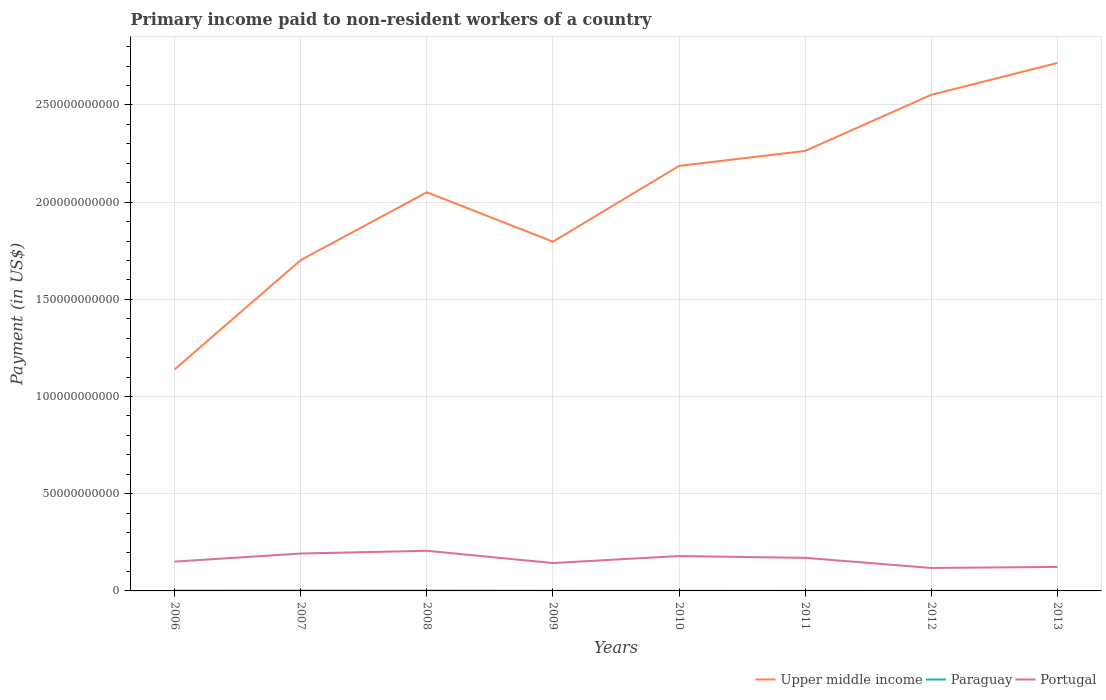Does the line corresponding to Paraguay intersect with the line corresponding to Upper middle income?
Provide a succinct answer. No. Is the number of lines equal to the number of legend labels?
Keep it short and to the point. Yes. Across all years, what is the maximum amount paid to workers in Upper middle income?
Your response must be concise. 1.14e+11. In which year was the amount paid to workers in Paraguay maximum?
Provide a short and direct response. 2011. What is the total amount paid to workers in Upper middle income in the graph?
Keep it short and to the point. -9.45e+09. What is the difference between the highest and the second highest amount paid to workers in Upper middle income?
Offer a very short reply. 1.58e+11. How many years are there in the graph?
Keep it short and to the point. 8. How many legend labels are there?
Offer a terse response. 3. How are the legend labels stacked?
Make the answer very short. Horizontal. What is the title of the graph?
Your answer should be compact. Primary income paid to non-resident workers of a country. Does "Ireland" appear as one of the legend labels in the graph?
Your response must be concise. No. What is the label or title of the Y-axis?
Your answer should be very brief. Payment (in US$). What is the Payment (in US$) of Upper middle income in 2006?
Offer a terse response. 1.14e+11. What is the Payment (in US$) of Paraguay in 2006?
Your response must be concise. 1.44e+08. What is the Payment (in US$) of Portugal in 2006?
Provide a short and direct response. 1.51e+1. What is the Payment (in US$) in Upper middle income in 2007?
Provide a succinct answer. 1.70e+11. What is the Payment (in US$) of Paraguay in 2007?
Ensure brevity in your answer.  1.68e+08. What is the Payment (in US$) in Portugal in 2007?
Provide a succinct answer. 1.92e+1. What is the Payment (in US$) in Upper middle income in 2008?
Offer a terse response. 2.05e+11. What is the Payment (in US$) in Paraguay in 2008?
Provide a succinct answer. 1.39e+08. What is the Payment (in US$) in Portugal in 2008?
Your answer should be very brief. 2.06e+1. What is the Payment (in US$) in Upper middle income in 2009?
Offer a very short reply. 1.80e+11. What is the Payment (in US$) in Paraguay in 2009?
Ensure brevity in your answer.  7.82e+07. What is the Payment (in US$) of Portugal in 2009?
Provide a succinct answer. 1.43e+1. What is the Payment (in US$) of Upper middle income in 2010?
Offer a very short reply. 2.19e+11. What is the Payment (in US$) in Paraguay in 2010?
Ensure brevity in your answer.  4.54e+07. What is the Payment (in US$) in Portugal in 2010?
Offer a very short reply. 1.80e+1. What is the Payment (in US$) in Upper middle income in 2011?
Make the answer very short. 2.26e+11. What is the Payment (in US$) in Paraguay in 2011?
Give a very brief answer. 3.59e+07. What is the Payment (in US$) in Portugal in 2011?
Provide a succinct answer. 1.70e+1. What is the Payment (in US$) in Upper middle income in 2012?
Give a very brief answer. 2.55e+11. What is the Payment (in US$) in Paraguay in 2012?
Provide a short and direct response. 4.21e+07. What is the Payment (in US$) of Portugal in 2012?
Provide a short and direct response. 1.18e+1. What is the Payment (in US$) of Upper middle income in 2013?
Your answer should be compact. 2.72e+11. What is the Payment (in US$) in Paraguay in 2013?
Give a very brief answer. 4.20e+07. What is the Payment (in US$) of Portugal in 2013?
Your response must be concise. 1.23e+1. Across all years, what is the maximum Payment (in US$) in Upper middle income?
Offer a very short reply. 2.72e+11. Across all years, what is the maximum Payment (in US$) of Paraguay?
Ensure brevity in your answer.  1.68e+08. Across all years, what is the maximum Payment (in US$) in Portugal?
Provide a short and direct response. 2.06e+1. Across all years, what is the minimum Payment (in US$) in Upper middle income?
Your answer should be very brief. 1.14e+11. Across all years, what is the minimum Payment (in US$) of Paraguay?
Your response must be concise. 3.59e+07. Across all years, what is the minimum Payment (in US$) in Portugal?
Provide a short and direct response. 1.18e+1. What is the total Payment (in US$) of Upper middle income in the graph?
Your answer should be very brief. 1.64e+12. What is the total Payment (in US$) of Paraguay in the graph?
Keep it short and to the point. 6.96e+08. What is the total Payment (in US$) in Portugal in the graph?
Your answer should be compact. 1.28e+11. What is the difference between the Payment (in US$) in Upper middle income in 2006 and that in 2007?
Provide a short and direct response. -5.63e+1. What is the difference between the Payment (in US$) in Paraguay in 2006 and that in 2007?
Offer a terse response. -2.44e+07. What is the difference between the Payment (in US$) in Portugal in 2006 and that in 2007?
Your answer should be very brief. -4.16e+09. What is the difference between the Payment (in US$) of Upper middle income in 2006 and that in 2008?
Your answer should be very brief. -9.11e+1. What is the difference between the Payment (in US$) of Paraguay in 2006 and that in 2008?
Provide a succinct answer. 4.57e+06. What is the difference between the Payment (in US$) in Portugal in 2006 and that in 2008?
Your response must be concise. -5.55e+09. What is the difference between the Payment (in US$) in Upper middle income in 2006 and that in 2009?
Your answer should be compact. -6.57e+1. What is the difference between the Payment (in US$) in Paraguay in 2006 and that in 2009?
Your response must be concise. 6.58e+07. What is the difference between the Payment (in US$) of Portugal in 2006 and that in 2009?
Your answer should be very brief. 7.43e+08. What is the difference between the Payment (in US$) in Upper middle income in 2006 and that in 2010?
Offer a very short reply. -1.05e+11. What is the difference between the Payment (in US$) in Paraguay in 2006 and that in 2010?
Your answer should be compact. 9.87e+07. What is the difference between the Payment (in US$) of Portugal in 2006 and that in 2010?
Provide a succinct answer. -2.87e+09. What is the difference between the Payment (in US$) of Upper middle income in 2006 and that in 2011?
Give a very brief answer. -1.12e+11. What is the difference between the Payment (in US$) in Paraguay in 2006 and that in 2011?
Make the answer very short. 1.08e+08. What is the difference between the Payment (in US$) in Portugal in 2006 and that in 2011?
Offer a very short reply. -1.92e+09. What is the difference between the Payment (in US$) in Upper middle income in 2006 and that in 2012?
Your answer should be very brief. -1.41e+11. What is the difference between the Payment (in US$) in Paraguay in 2006 and that in 2012?
Offer a very short reply. 1.02e+08. What is the difference between the Payment (in US$) of Portugal in 2006 and that in 2012?
Offer a terse response. 3.27e+09. What is the difference between the Payment (in US$) in Upper middle income in 2006 and that in 2013?
Offer a terse response. -1.58e+11. What is the difference between the Payment (in US$) in Paraguay in 2006 and that in 2013?
Make the answer very short. 1.02e+08. What is the difference between the Payment (in US$) of Portugal in 2006 and that in 2013?
Make the answer very short. 2.74e+09. What is the difference between the Payment (in US$) of Upper middle income in 2007 and that in 2008?
Keep it short and to the point. -3.49e+1. What is the difference between the Payment (in US$) in Paraguay in 2007 and that in 2008?
Give a very brief answer. 2.90e+07. What is the difference between the Payment (in US$) in Portugal in 2007 and that in 2008?
Offer a terse response. -1.40e+09. What is the difference between the Payment (in US$) of Upper middle income in 2007 and that in 2009?
Keep it short and to the point. -9.45e+09. What is the difference between the Payment (in US$) of Paraguay in 2007 and that in 2009?
Keep it short and to the point. 9.02e+07. What is the difference between the Payment (in US$) of Portugal in 2007 and that in 2009?
Provide a succinct answer. 4.90e+09. What is the difference between the Payment (in US$) in Upper middle income in 2007 and that in 2010?
Provide a succinct answer. -4.84e+1. What is the difference between the Payment (in US$) of Paraguay in 2007 and that in 2010?
Keep it short and to the point. 1.23e+08. What is the difference between the Payment (in US$) in Portugal in 2007 and that in 2010?
Provide a short and direct response. 1.29e+09. What is the difference between the Payment (in US$) of Upper middle income in 2007 and that in 2011?
Provide a succinct answer. -5.61e+1. What is the difference between the Payment (in US$) in Paraguay in 2007 and that in 2011?
Your answer should be very brief. 1.33e+08. What is the difference between the Payment (in US$) in Portugal in 2007 and that in 2011?
Provide a short and direct response. 2.23e+09. What is the difference between the Payment (in US$) of Upper middle income in 2007 and that in 2012?
Your answer should be very brief. -8.50e+1. What is the difference between the Payment (in US$) of Paraguay in 2007 and that in 2012?
Your answer should be compact. 1.26e+08. What is the difference between the Payment (in US$) in Portugal in 2007 and that in 2012?
Provide a short and direct response. 7.43e+09. What is the difference between the Payment (in US$) of Upper middle income in 2007 and that in 2013?
Your answer should be very brief. -1.01e+11. What is the difference between the Payment (in US$) of Paraguay in 2007 and that in 2013?
Ensure brevity in your answer.  1.26e+08. What is the difference between the Payment (in US$) of Portugal in 2007 and that in 2013?
Your response must be concise. 6.90e+09. What is the difference between the Payment (in US$) of Upper middle income in 2008 and that in 2009?
Your answer should be very brief. 2.54e+1. What is the difference between the Payment (in US$) of Paraguay in 2008 and that in 2009?
Your response must be concise. 6.12e+07. What is the difference between the Payment (in US$) in Portugal in 2008 and that in 2009?
Keep it short and to the point. 6.30e+09. What is the difference between the Payment (in US$) of Upper middle income in 2008 and that in 2010?
Provide a short and direct response. -1.36e+1. What is the difference between the Payment (in US$) in Paraguay in 2008 and that in 2010?
Offer a very short reply. 9.41e+07. What is the difference between the Payment (in US$) in Portugal in 2008 and that in 2010?
Your answer should be compact. 2.69e+09. What is the difference between the Payment (in US$) in Upper middle income in 2008 and that in 2011?
Make the answer very short. -2.13e+1. What is the difference between the Payment (in US$) of Paraguay in 2008 and that in 2011?
Your response must be concise. 1.04e+08. What is the difference between the Payment (in US$) of Portugal in 2008 and that in 2011?
Give a very brief answer. 3.63e+09. What is the difference between the Payment (in US$) of Upper middle income in 2008 and that in 2012?
Your answer should be very brief. -5.01e+1. What is the difference between the Payment (in US$) of Paraguay in 2008 and that in 2012?
Make the answer very short. 9.74e+07. What is the difference between the Payment (in US$) in Portugal in 2008 and that in 2012?
Make the answer very short. 8.83e+09. What is the difference between the Payment (in US$) of Upper middle income in 2008 and that in 2013?
Offer a terse response. -6.65e+1. What is the difference between the Payment (in US$) in Paraguay in 2008 and that in 2013?
Give a very brief answer. 9.74e+07. What is the difference between the Payment (in US$) in Portugal in 2008 and that in 2013?
Give a very brief answer. 8.30e+09. What is the difference between the Payment (in US$) in Upper middle income in 2009 and that in 2010?
Offer a terse response. -3.90e+1. What is the difference between the Payment (in US$) in Paraguay in 2009 and that in 2010?
Make the answer very short. 3.29e+07. What is the difference between the Payment (in US$) in Portugal in 2009 and that in 2010?
Provide a short and direct response. -3.61e+09. What is the difference between the Payment (in US$) in Upper middle income in 2009 and that in 2011?
Your answer should be compact. -4.67e+1. What is the difference between the Payment (in US$) of Paraguay in 2009 and that in 2011?
Make the answer very short. 4.24e+07. What is the difference between the Payment (in US$) in Portugal in 2009 and that in 2011?
Make the answer very short. -2.67e+09. What is the difference between the Payment (in US$) in Upper middle income in 2009 and that in 2012?
Make the answer very short. -7.55e+1. What is the difference between the Payment (in US$) in Paraguay in 2009 and that in 2012?
Offer a very short reply. 3.61e+07. What is the difference between the Payment (in US$) of Portugal in 2009 and that in 2012?
Keep it short and to the point. 2.53e+09. What is the difference between the Payment (in US$) of Upper middle income in 2009 and that in 2013?
Make the answer very short. -9.19e+1. What is the difference between the Payment (in US$) of Paraguay in 2009 and that in 2013?
Provide a succinct answer. 3.62e+07. What is the difference between the Payment (in US$) in Portugal in 2009 and that in 2013?
Give a very brief answer. 2.00e+09. What is the difference between the Payment (in US$) in Upper middle income in 2010 and that in 2011?
Keep it short and to the point. -7.73e+09. What is the difference between the Payment (in US$) in Paraguay in 2010 and that in 2011?
Make the answer very short. 9.53e+06. What is the difference between the Payment (in US$) of Portugal in 2010 and that in 2011?
Give a very brief answer. 9.44e+08. What is the difference between the Payment (in US$) in Upper middle income in 2010 and that in 2012?
Provide a succinct answer. -3.66e+1. What is the difference between the Payment (in US$) of Paraguay in 2010 and that in 2012?
Give a very brief answer. 3.28e+06. What is the difference between the Payment (in US$) of Portugal in 2010 and that in 2012?
Your response must be concise. 6.14e+09. What is the difference between the Payment (in US$) of Upper middle income in 2010 and that in 2013?
Provide a succinct answer. -5.30e+1. What is the difference between the Payment (in US$) in Paraguay in 2010 and that in 2013?
Keep it short and to the point. 3.33e+06. What is the difference between the Payment (in US$) in Portugal in 2010 and that in 2013?
Offer a very short reply. 5.61e+09. What is the difference between the Payment (in US$) in Upper middle income in 2011 and that in 2012?
Your answer should be compact. -2.88e+1. What is the difference between the Payment (in US$) of Paraguay in 2011 and that in 2012?
Your response must be concise. -6.25e+06. What is the difference between the Payment (in US$) of Portugal in 2011 and that in 2012?
Offer a very short reply. 5.20e+09. What is the difference between the Payment (in US$) in Upper middle income in 2011 and that in 2013?
Keep it short and to the point. -4.52e+1. What is the difference between the Payment (in US$) of Paraguay in 2011 and that in 2013?
Offer a terse response. -6.20e+06. What is the difference between the Payment (in US$) in Portugal in 2011 and that in 2013?
Offer a terse response. 4.67e+09. What is the difference between the Payment (in US$) in Upper middle income in 2012 and that in 2013?
Your answer should be very brief. -1.64e+1. What is the difference between the Payment (in US$) of Paraguay in 2012 and that in 2013?
Ensure brevity in your answer.  5.16e+04. What is the difference between the Payment (in US$) in Portugal in 2012 and that in 2013?
Give a very brief answer. -5.29e+08. What is the difference between the Payment (in US$) of Upper middle income in 2006 and the Payment (in US$) of Paraguay in 2007?
Provide a short and direct response. 1.14e+11. What is the difference between the Payment (in US$) in Upper middle income in 2006 and the Payment (in US$) in Portugal in 2007?
Make the answer very short. 9.47e+1. What is the difference between the Payment (in US$) in Paraguay in 2006 and the Payment (in US$) in Portugal in 2007?
Ensure brevity in your answer.  -1.91e+1. What is the difference between the Payment (in US$) in Upper middle income in 2006 and the Payment (in US$) in Paraguay in 2008?
Ensure brevity in your answer.  1.14e+11. What is the difference between the Payment (in US$) of Upper middle income in 2006 and the Payment (in US$) of Portugal in 2008?
Your response must be concise. 9.33e+1. What is the difference between the Payment (in US$) in Paraguay in 2006 and the Payment (in US$) in Portugal in 2008?
Keep it short and to the point. -2.05e+1. What is the difference between the Payment (in US$) in Upper middle income in 2006 and the Payment (in US$) in Paraguay in 2009?
Provide a short and direct response. 1.14e+11. What is the difference between the Payment (in US$) of Upper middle income in 2006 and the Payment (in US$) of Portugal in 2009?
Provide a short and direct response. 9.96e+1. What is the difference between the Payment (in US$) in Paraguay in 2006 and the Payment (in US$) in Portugal in 2009?
Keep it short and to the point. -1.42e+1. What is the difference between the Payment (in US$) in Upper middle income in 2006 and the Payment (in US$) in Paraguay in 2010?
Your answer should be very brief. 1.14e+11. What is the difference between the Payment (in US$) in Upper middle income in 2006 and the Payment (in US$) in Portugal in 2010?
Keep it short and to the point. 9.60e+1. What is the difference between the Payment (in US$) of Paraguay in 2006 and the Payment (in US$) of Portugal in 2010?
Ensure brevity in your answer.  -1.78e+1. What is the difference between the Payment (in US$) in Upper middle income in 2006 and the Payment (in US$) in Paraguay in 2011?
Your answer should be very brief. 1.14e+11. What is the difference between the Payment (in US$) in Upper middle income in 2006 and the Payment (in US$) in Portugal in 2011?
Make the answer very short. 9.70e+1. What is the difference between the Payment (in US$) in Paraguay in 2006 and the Payment (in US$) in Portugal in 2011?
Provide a succinct answer. -1.69e+1. What is the difference between the Payment (in US$) of Upper middle income in 2006 and the Payment (in US$) of Paraguay in 2012?
Offer a terse response. 1.14e+11. What is the difference between the Payment (in US$) in Upper middle income in 2006 and the Payment (in US$) in Portugal in 2012?
Your answer should be compact. 1.02e+11. What is the difference between the Payment (in US$) of Paraguay in 2006 and the Payment (in US$) of Portugal in 2012?
Your response must be concise. -1.17e+1. What is the difference between the Payment (in US$) of Upper middle income in 2006 and the Payment (in US$) of Paraguay in 2013?
Provide a short and direct response. 1.14e+11. What is the difference between the Payment (in US$) in Upper middle income in 2006 and the Payment (in US$) in Portugal in 2013?
Provide a succinct answer. 1.02e+11. What is the difference between the Payment (in US$) of Paraguay in 2006 and the Payment (in US$) of Portugal in 2013?
Give a very brief answer. -1.22e+1. What is the difference between the Payment (in US$) of Upper middle income in 2007 and the Payment (in US$) of Paraguay in 2008?
Offer a terse response. 1.70e+11. What is the difference between the Payment (in US$) of Upper middle income in 2007 and the Payment (in US$) of Portugal in 2008?
Offer a very short reply. 1.50e+11. What is the difference between the Payment (in US$) in Paraguay in 2007 and the Payment (in US$) in Portugal in 2008?
Ensure brevity in your answer.  -2.05e+1. What is the difference between the Payment (in US$) in Upper middle income in 2007 and the Payment (in US$) in Paraguay in 2009?
Offer a very short reply. 1.70e+11. What is the difference between the Payment (in US$) of Upper middle income in 2007 and the Payment (in US$) of Portugal in 2009?
Offer a very short reply. 1.56e+11. What is the difference between the Payment (in US$) of Paraguay in 2007 and the Payment (in US$) of Portugal in 2009?
Offer a terse response. -1.42e+1. What is the difference between the Payment (in US$) in Upper middle income in 2007 and the Payment (in US$) in Paraguay in 2010?
Provide a short and direct response. 1.70e+11. What is the difference between the Payment (in US$) of Upper middle income in 2007 and the Payment (in US$) of Portugal in 2010?
Give a very brief answer. 1.52e+11. What is the difference between the Payment (in US$) of Paraguay in 2007 and the Payment (in US$) of Portugal in 2010?
Keep it short and to the point. -1.78e+1. What is the difference between the Payment (in US$) of Upper middle income in 2007 and the Payment (in US$) of Paraguay in 2011?
Provide a short and direct response. 1.70e+11. What is the difference between the Payment (in US$) of Upper middle income in 2007 and the Payment (in US$) of Portugal in 2011?
Your answer should be compact. 1.53e+11. What is the difference between the Payment (in US$) of Paraguay in 2007 and the Payment (in US$) of Portugal in 2011?
Ensure brevity in your answer.  -1.68e+1. What is the difference between the Payment (in US$) in Upper middle income in 2007 and the Payment (in US$) in Paraguay in 2012?
Keep it short and to the point. 1.70e+11. What is the difference between the Payment (in US$) in Upper middle income in 2007 and the Payment (in US$) in Portugal in 2012?
Your answer should be very brief. 1.58e+11. What is the difference between the Payment (in US$) of Paraguay in 2007 and the Payment (in US$) of Portugal in 2012?
Provide a succinct answer. -1.16e+1. What is the difference between the Payment (in US$) of Upper middle income in 2007 and the Payment (in US$) of Paraguay in 2013?
Your response must be concise. 1.70e+11. What is the difference between the Payment (in US$) in Upper middle income in 2007 and the Payment (in US$) in Portugal in 2013?
Keep it short and to the point. 1.58e+11. What is the difference between the Payment (in US$) in Paraguay in 2007 and the Payment (in US$) in Portugal in 2013?
Ensure brevity in your answer.  -1.22e+1. What is the difference between the Payment (in US$) in Upper middle income in 2008 and the Payment (in US$) in Paraguay in 2009?
Your answer should be very brief. 2.05e+11. What is the difference between the Payment (in US$) of Upper middle income in 2008 and the Payment (in US$) of Portugal in 2009?
Offer a very short reply. 1.91e+11. What is the difference between the Payment (in US$) of Paraguay in 2008 and the Payment (in US$) of Portugal in 2009?
Ensure brevity in your answer.  -1.42e+1. What is the difference between the Payment (in US$) in Upper middle income in 2008 and the Payment (in US$) in Paraguay in 2010?
Keep it short and to the point. 2.05e+11. What is the difference between the Payment (in US$) of Upper middle income in 2008 and the Payment (in US$) of Portugal in 2010?
Provide a short and direct response. 1.87e+11. What is the difference between the Payment (in US$) in Paraguay in 2008 and the Payment (in US$) in Portugal in 2010?
Your answer should be compact. -1.78e+1. What is the difference between the Payment (in US$) in Upper middle income in 2008 and the Payment (in US$) in Paraguay in 2011?
Provide a short and direct response. 2.05e+11. What is the difference between the Payment (in US$) of Upper middle income in 2008 and the Payment (in US$) of Portugal in 2011?
Provide a succinct answer. 1.88e+11. What is the difference between the Payment (in US$) in Paraguay in 2008 and the Payment (in US$) in Portugal in 2011?
Your response must be concise. -1.69e+1. What is the difference between the Payment (in US$) in Upper middle income in 2008 and the Payment (in US$) in Paraguay in 2012?
Make the answer very short. 2.05e+11. What is the difference between the Payment (in US$) in Upper middle income in 2008 and the Payment (in US$) in Portugal in 2012?
Offer a terse response. 1.93e+11. What is the difference between the Payment (in US$) of Paraguay in 2008 and the Payment (in US$) of Portugal in 2012?
Give a very brief answer. -1.17e+1. What is the difference between the Payment (in US$) in Upper middle income in 2008 and the Payment (in US$) in Paraguay in 2013?
Keep it short and to the point. 2.05e+11. What is the difference between the Payment (in US$) of Upper middle income in 2008 and the Payment (in US$) of Portugal in 2013?
Your answer should be compact. 1.93e+11. What is the difference between the Payment (in US$) of Paraguay in 2008 and the Payment (in US$) of Portugal in 2013?
Provide a succinct answer. -1.22e+1. What is the difference between the Payment (in US$) of Upper middle income in 2009 and the Payment (in US$) of Paraguay in 2010?
Provide a short and direct response. 1.80e+11. What is the difference between the Payment (in US$) in Upper middle income in 2009 and the Payment (in US$) in Portugal in 2010?
Provide a succinct answer. 1.62e+11. What is the difference between the Payment (in US$) of Paraguay in 2009 and the Payment (in US$) of Portugal in 2010?
Your answer should be very brief. -1.79e+1. What is the difference between the Payment (in US$) in Upper middle income in 2009 and the Payment (in US$) in Paraguay in 2011?
Make the answer very short. 1.80e+11. What is the difference between the Payment (in US$) in Upper middle income in 2009 and the Payment (in US$) in Portugal in 2011?
Ensure brevity in your answer.  1.63e+11. What is the difference between the Payment (in US$) of Paraguay in 2009 and the Payment (in US$) of Portugal in 2011?
Offer a very short reply. -1.69e+1. What is the difference between the Payment (in US$) of Upper middle income in 2009 and the Payment (in US$) of Paraguay in 2012?
Provide a short and direct response. 1.80e+11. What is the difference between the Payment (in US$) of Upper middle income in 2009 and the Payment (in US$) of Portugal in 2012?
Make the answer very short. 1.68e+11. What is the difference between the Payment (in US$) in Paraguay in 2009 and the Payment (in US$) in Portugal in 2012?
Make the answer very short. -1.17e+1. What is the difference between the Payment (in US$) in Upper middle income in 2009 and the Payment (in US$) in Paraguay in 2013?
Your answer should be compact. 1.80e+11. What is the difference between the Payment (in US$) of Upper middle income in 2009 and the Payment (in US$) of Portugal in 2013?
Your response must be concise. 1.67e+11. What is the difference between the Payment (in US$) in Paraguay in 2009 and the Payment (in US$) in Portugal in 2013?
Give a very brief answer. -1.23e+1. What is the difference between the Payment (in US$) of Upper middle income in 2010 and the Payment (in US$) of Paraguay in 2011?
Give a very brief answer. 2.19e+11. What is the difference between the Payment (in US$) in Upper middle income in 2010 and the Payment (in US$) in Portugal in 2011?
Your response must be concise. 2.02e+11. What is the difference between the Payment (in US$) of Paraguay in 2010 and the Payment (in US$) of Portugal in 2011?
Keep it short and to the point. -1.70e+1. What is the difference between the Payment (in US$) in Upper middle income in 2010 and the Payment (in US$) in Paraguay in 2012?
Provide a succinct answer. 2.19e+11. What is the difference between the Payment (in US$) in Upper middle income in 2010 and the Payment (in US$) in Portugal in 2012?
Your answer should be very brief. 2.07e+11. What is the difference between the Payment (in US$) of Paraguay in 2010 and the Payment (in US$) of Portugal in 2012?
Offer a very short reply. -1.18e+1. What is the difference between the Payment (in US$) of Upper middle income in 2010 and the Payment (in US$) of Paraguay in 2013?
Provide a succinct answer. 2.19e+11. What is the difference between the Payment (in US$) in Upper middle income in 2010 and the Payment (in US$) in Portugal in 2013?
Make the answer very short. 2.06e+11. What is the difference between the Payment (in US$) of Paraguay in 2010 and the Payment (in US$) of Portugal in 2013?
Provide a succinct answer. -1.23e+1. What is the difference between the Payment (in US$) in Upper middle income in 2011 and the Payment (in US$) in Paraguay in 2012?
Ensure brevity in your answer.  2.26e+11. What is the difference between the Payment (in US$) of Upper middle income in 2011 and the Payment (in US$) of Portugal in 2012?
Keep it short and to the point. 2.15e+11. What is the difference between the Payment (in US$) of Paraguay in 2011 and the Payment (in US$) of Portugal in 2012?
Ensure brevity in your answer.  -1.18e+1. What is the difference between the Payment (in US$) of Upper middle income in 2011 and the Payment (in US$) of Paraguay in 2013?
Your answer should be compact. 2.26e+11. What is the difference between the Payment (in US$) in Upper middle income in 2011 and the Payment (in US$) in Portugal in 2013?
Offer a terse response. 2.14e+11. What is the difference between the Payment (in US$) of Paraguay in 2011 and the Payment (in US$) of Portugal in 2013?
Provide a short and direct response. -1.23e+1. What is the difference between the Payment (in US$) in Upper middle income in 2012 and the Payment (in US$) in Paraguay in 2013?
Ensure brevity in your answer.  2.55e+11. What is the difference between the Payment (in US$) of Upper middle income in 2012 and the Payment (in US$) of Portugal in 2013?
Offer a very short reply. 2.43e+11. What is the difference between the Payment (in US$) in Paraguay in 2012 and the Payment (in US$) in Portugal in 2013?
Provide a short and direct response. -1.23e+1. What is the average Payment (in US$) in Upper middle income per year?
Ensure brevity in your answer.  2.05e+11. What is the average Payment (in US$) of Paraguay per year?
Offer a terse response. 8.69e+07. What is the average Payment (in US$) in Portugal per year?
Ensure brevity in your answer.  1.61e+1. In the year 2006, what is the difference between the Payment (in US$) in Upper middle income and Payment (in US$) in Paraguay?
Ensure brevity in your answer.  1.14e+11. In the year 2006, what is the difference between the Payment (in US$) of Upper middle income and Payment (in US$) of Portugal?
Provide a succinct answer. 9.89e+1. In the year 2006, what is the difference between the Payment (in US$) in Paraguay and Payment (in US$) in Portugal?
Provide a short and direct response. -1.49e+1. In the year 2007, what is the difference between the Payment (in US$) in Upper middle income and Payment (in US$) in Paraguay?
Offer a very short reply. 1.70e+11. In the year 2007, what is the difference between the Payment (in US$) of Upper middle income and Payment (in US$) of Portugal?
Give a very brief answer. 1.51e+11. In the year 2007, what is the difference between the Payment (in US$) in Paraguay and Payment (in US$) in Portugal?
Your response must be concise. -1.91e+1. In the year 2008, what is the difference between the Payment (in US$) of Upper middle income and Payment (in US$) of Paraguay?
Make the answer very short. 2.05e+11. In the year 2008, what is the difference between the Payment (in US$) of Upper middle income and Payment (in US$) of Portugal?
Make the answer very short. 1.84e+11. In the year 2008, what is the difference between the Payment (in US$) of Paraguay and Payment (in US$) of Portugal?
Provide a succinct answer. -2.05e+1. In the year 2009, what is the difference between the Payment (in US$) of Upper middle income and Payment (in US$) of Paraguay?
Your answer should be very brief. 1.80e+11. In the year 2009, what is the difference between the Payment (in US$) of Upper middle income and Payment (in US$) of Portugal?
Your answer should be compact. 1.65e+11. In the year 2009, what is the difference between the Payment (in US$) in Paraguay and Payment (in US$) in Portugal?
Make the answer very short. -1.43e+1. In the year 2010, what is the difference between the Payment (in US$) of Upper middle income and Payment (in US$) of Paraguay?
Provide a succinct answer. 2.19e+11. In the year 2010, what is the difference between the Payment (in US$) in Upper middle income and Payment (in US$) in Portugal?
Keep it short and to the point. 2.01e+11. In the year 2010, what is the difference between the Payment (in US$) in Paraguay and Payment (in US$) in Portugal?
Your answer should be very brief. -1.79e+1. In the year 2011, what is the difference between the Payment (in US$) in Upper middle income and Payment (in US$) in Paraguay?
Give a very brief answer. 2.26e+11. In the year 2011, what is the difference between the Payment (in US$) in Upper middle income and Payment (in US$) in Portugal?
Offer a very short reply. 2.09e+11. In the year 2011, what is the difference between the Payment (in US$) of Paraguay and Payment (in US$) of Portugal?
Your answer should be very brief. -1.70e+1. In the year 2012, what is the difference between the Payment (in US$) of Upper middle income and Payment (in US$) of Paraguay?
Provide a succinct answer. 2.55e+11. In the year 2012, what is the difference between the Payment (in US$) in Upper middle income and Payment (in US$) in Portugal?
Your answer should be compact. 2.43e+11. In the year 2012, what is the difference between the Payment (in US$) of Paraguay and Payment (in US$) of Portugal?
Provide a short and direct response. -1.18e+1. In the year 2013, what is the difference between the Payment (in US$) of Upper middle income and Payment (in US$) of Paraguay?
Your answer should be compact. 2.72e+11. In the year 2013, what is the difference between the Payment (in US$) in Upper middle income and Payment (in US$) in Portugal?
Offer a very short reply. 2.59e+11. In the year 2013, what is the difference between the Payment (in US$) in Paraguay and Payment (in US$) in Portugal?
Offer a very short reply. -1.23e+1. What is the ratio of the Payment (in US$) in Upper middle income in 2006 to that in 2007?
Offer a very short reply. 0.67. What is the ratio of the Payment (in US$) of Paraguay in 2006 to that in 2007?
Provide a short and direct response. 0.86. What is the ratio of the Payment (in US$) of Portugal in 2006 to that in 2007?
Give a very brief answer. 0.78. What is the ratio of the Payment (in US$) in Upper middle income in 2006 to that in 2008?
Your answer should be very brief. 0.56. What is the ratio of the Payment (in US$) of Paraguay in 2006 to that in 2008?
Your answer should be compact. 1.03. What is the ratio of the Payment (in US$) of Portugal in 2006 to that in 2008?
Provide a succinct answer. 0.73. What is the ratio of the Payment (in US$) of Upper middle income in 2006 to that in 2009?
Ensure brevity in your answer.  0.63. What is the ratio of the Payment (in US$) in Paraguay in 2006 to that in 2009?
Offer a terse response. 1.84. What is the ratio of the Payment (in US$) of Portugal in 2006 to that in 2009?
Your response must be concise. 1.05. What is the ratio of the Payment (in US$) of Upper middle income in 2006 to that in 2010?
Ensure brevity in your answer.  0.52. What is the ratio of the Payment (in US$) in Paraguay in 2006 to that in 2010?
Your answer should be very brief. 3.17. What is the ratio of the Payment (in US$) in Portugal in 2006 to that in 2010?
Offer a very short reply. 0.84. What is the ratio of the Payment (in US$) of Upper middle income in 2006 to that in 2011?
Give a very brief answer. 0.5. What is the ratio of the Payment (in US$) in Paraguay in 2006 to that in 2011?
Ensure brevity in your answer.  4.02. What is the ratio of the Payment (in US$) in Portugal in 2006 to that in 2011?
Keep it short and to the point. 0.89. What is the ratio of the Payment (in US$) of Upper middle income in 2006 to that in 2012?
Provide a short and direct response. 0.45. What is the ratio of the Payment (in US$) of Paraguay in 2006 to that in 2012?
Offer a very short reply. 3.42. What is the ratio of the Payment (in US$) of Portugal in 2006 to that in 2012?
Ensure brevity in your answer.  1.28. What is the ratio of the Payment (in US$) in Upper middle income in 2006 to that in 2013?
Provide a succinct answer. 0.42. What is the ratio of the Payment (in US$) in Paraguay in 2006 to that in 2013?
Keep it short and to the point. 3.43. What is the ratio of the Payment (in US$) of Portugal in 2006 to that in 2013?
Your answer should be compact. 1.22. What is the ratio of the Payment (in US$) in Upper middle income in 2007 to that in 2008?
Offer a terse response. 0.83. What is the ratio of the Payment (in US$) in Paraguay in 2007 to that in 2008?
Give a very brief answer. 1.21. What is the ratio of the Payment (in US$) in Portugal in 2007 to that in 2008?
Your response must be concise. 0.93. What is the ratio of the Payment (in US$) of Paraguay in 2007 to that in 2009?
Make the answer very short. 2.15. What is the ratio of the Payment (in US$) of Portugal in 2007 to that in 2009?
Your answer should be compact. 1.34. What is the ratio of the Payment (in US$) in Upper middle income in 2007 to that in 2010?
Ensure brevity in your answer.  0.78. What is the ratio of the Payment (in US$) in Paraguay in 2007 to that in 2010?
Your response must be concise. 3.71. What is the ratio of the Payment (in US$) in Portugal in 2007 to that in 2010?
Your answer should be very brief. 1.07. What is the ratio of the Payment (in US$) in Upper middle income in 2007 to that in 2011?
Your answer should be compact. 0.75. What is the ratio of the Payment (in US$) in Paraguay in 2007 to that in 2011?
Your answer should be very brief. 4.7. What is the ratio of the Payment (in US$) in Portugal in 2007 to that in 2011?
Offer a terse response. 1.13. What is the ratio of the Payment (in US$) of Upper middle income in 2007 to that in 2012?
Give a very brief answer. 0.67. What is the ratio of the Payment (in US$) of Paraguay in 2007 to that in 2012?
Provide a short and direct response. 4. What is the ratio of the Payment (in US$) of Portugal in 2007 to that in 2012?
Keep it short and to the point. 1.63. What is the ratio of the Payment (in US$) of Upper middle income in 2007 to that in 2013?
Give a very brief answer. 0.63. What is the ratio of the Payment (in US$) of Paraguay in 2007 to that in 2013?
Provide a short and direct response. 4.01. What is the ratio of the Payment (in US$) of Portugal in 2007 to that in 2013?
Your answer should be compact. 1.56. What is the ratio of the Payment (in US$) of Upper middle income in 2008 to that in 2009?
Your answer should be very brief. 1.14. What is the ratio of the Payment (in US$) of Paraguay in 2008 to that in 2009?
Your answer should be very brief. 1.78. What is the ratio of the Payment (in US$) of Portugal in 2008 to that in 2009?
Provide a succinct answer. 1.44. What is the ratio of the Payment (in US$) in Upper middle income in 2008 to that in 2010?
Your response must be concise. 0.94. What is the ratio of the Payment (in US$) in Paraguay in 2008 to that in 2010?
Offer a terse response. 3.07. What is the ratio of the Payment (in US$) in Portugal in 2008 to that in 2010?
Your answer should be very brief. 1.15. What is the ratio of the Payment (in US$) in Upper middle income in 2008 to that in 2011?
Make the answer very short. 0.91. What is the ratio of the Payment (in US$) in Paraguay in 2008 to that in 2011?
Offer a terse response. 3.89. What is the ratio of the Payment (in US$) of Portugal in 2008 to that in 2011?
Ensure brevity in your answer.  1.21. What is the ratio of the Payment (in US$) in Upper middle income in 2008 to that in 2012?
Your response must be concise. 0.8. What is the ratio of the Payment (in US$) in Paraguay in 2008 to that in 2012?
Provide a succinct answer. 3.31. What is the ratio of the Payment (in US$) in Portugal in 2008 to that in 2012?
Offer a very short reply. 1.75. What is the ratio of the Payment (in US$) in Upper middle income in 2008 to that in 2013?
Your response must be concise. 0.76. What is the ratio of the Payment (in US$) of Paraguay in 2008 to that in 2013?
Make the answer very short. 3.32. What is the ratio of the Payment (in US$) in Portugal in 2008 to that in 2013?
Provide a short and direct response. 1.67. What is the ratio of the Payment (in US$) in Upper middle income in 2009 to that in 2010?
Provide a short and direct response. 0.82. What is the ratio of the Payment (in US$) in Paraguay in 2009 to that in 2010?
Keep it short and to the point. 1.72. What is the ratio of the Payment (in US$) in Portugal in 2009 to that in 2010?
Give a very brief answer. 0.8. What is the ratio of the Payment (in US$) in Upper middle income in 2009 to that in 2011?
Make the answer very short. 0.79. What is the ratio of the Payment (in US$) in Paraguay in 2009 to that in 2011?
Your answer should be very brief. 2.18. What is the ratio of the Payment (in US$) in Portugal in 2009 to that in 2011?
Your answer should be compact. 0.84. What is the ratio of the Payment (in US$) in Upper middle income in 2009 to that in 2012?
Your answer should be very brief. 0.7. What is the ratio of the Payment (in US$) in Paraguay in 2009 to that in 2012?
Provide a short and direct response. 1.86. What is the ratio of the Payment (in US$) of Portugal in 2009 to that in 2012?
Provide a succinct answer. 1.21. What is the ratio of the Payment (in US$) of Upper middle income in 2009 to that in 2013?
Keep it short and to the point. 0.66. What is the ratio of the Payment (in US$) in Paraguay in 2009 to that in 2013?
Offer a terse response. 1.86. What is the ratio of the Payment (in US$) in Portugal in 2009 to that in 2013?
Offer a terse response. 1.16. What is the ratio of the Payment (in US$) in Upper middle income in 2010 to that in 2011?
Provide a short and direct response. 0.97. What is the ratio of the Payment (in US$) in Paraguay in 2010 to that in 2011?
Keep it short and to the point. 1.27. What is the ratio of the Payment (in US$) in Portugal in 2010 to that in 2011?
Your answer should be very brief. 1.06. What is the ratio of the Payment (in US$) in Upper middle income in 2010 to that in 2012?
Your answer should be very brief. 0.86. What is the ratio of the Payment (in US$) in Paraguay in 2010 to that in 2012?
Provide a succinct answer. 1.08. What is the ratio of the Payment (in US$) of Portugal in 2010 to that in 2012?
Keep it short and to the point. 1.52. What is the ratio of the Payment (in US$) of Upper middle income in 2010 to that in 2013?
Offer a very short reply. 0.81. What is the ratio of the Payment (in US$) in Paraguay in 2010 to that in 2013?
Make the answer very short. 1.08. What is the ratio of the Payment (in US$) of Portugal in 2010 to that in 2013?
Provide a short and direct response. 1.45. What is the ratio of the Payment (in US$) in Upper middle income in 2011 to that in 2012?
Make the answer very short. 0.89. What is the ratio of the Payment (in US$) of Paraguay in 2011 to that in 2012?
Offer a very short reply. 0.85. What is the ratio of the Payment (in US$) of Portugal in 2011 to that in 2012?
Offer a very short reply. 1.44. What is the ratio of the Payment (in US$) of Upper middle income in 2011 to that in 2013?
Provide a succinct answer. 0.83. What is the ratio of the Payment (in US$) in Paraguay in 2011 to that in 2013?
Your response must be concise. 0.85. What is the ratio of the Payment (in US$) of Portugal in 2011 to that in 2013?
Ensure brevity in your answer.  1.38. What is the ratio of the Payment (in US$) in Upper middle income in 2012 to that in 2013?
Provide a short and direct response. 0.94. What is the ratio of the Payment (in US$) of Paraguay in 2012 to that in 2013?
Provide a short and direct response. 1. What is the ratio of the Payment (in US$) in Portugal in 2012 to that in 2013?
Keep it short and to the point. 0.96. What is the difference between the highest and the second highest Payment (in US$) of Upper middle income?
Make the answer very short. 1.64e+1. What is the difference between the highest and the second highest Payment (in US$) in Paraguay?
Keep it short and to the point. 2.44e+07. What is the difference between the highest and the second highest Payment (in US$) in Portugal?
Provide a succinct answer. 1.40e+09. What is the difference between the highest and the lowest Payment (in US$) in Upper middle income?
Keep it short and to the point. 1.58e+11. What is the difference between the highest and the lowest Payment (in US$) of Paraguay?
Your response must be concise. 1.33e+08. What is the difference between the highest and the lowest Payment (in US$) of Portugal?
Keep it short and to the point. 8.83e+09. 